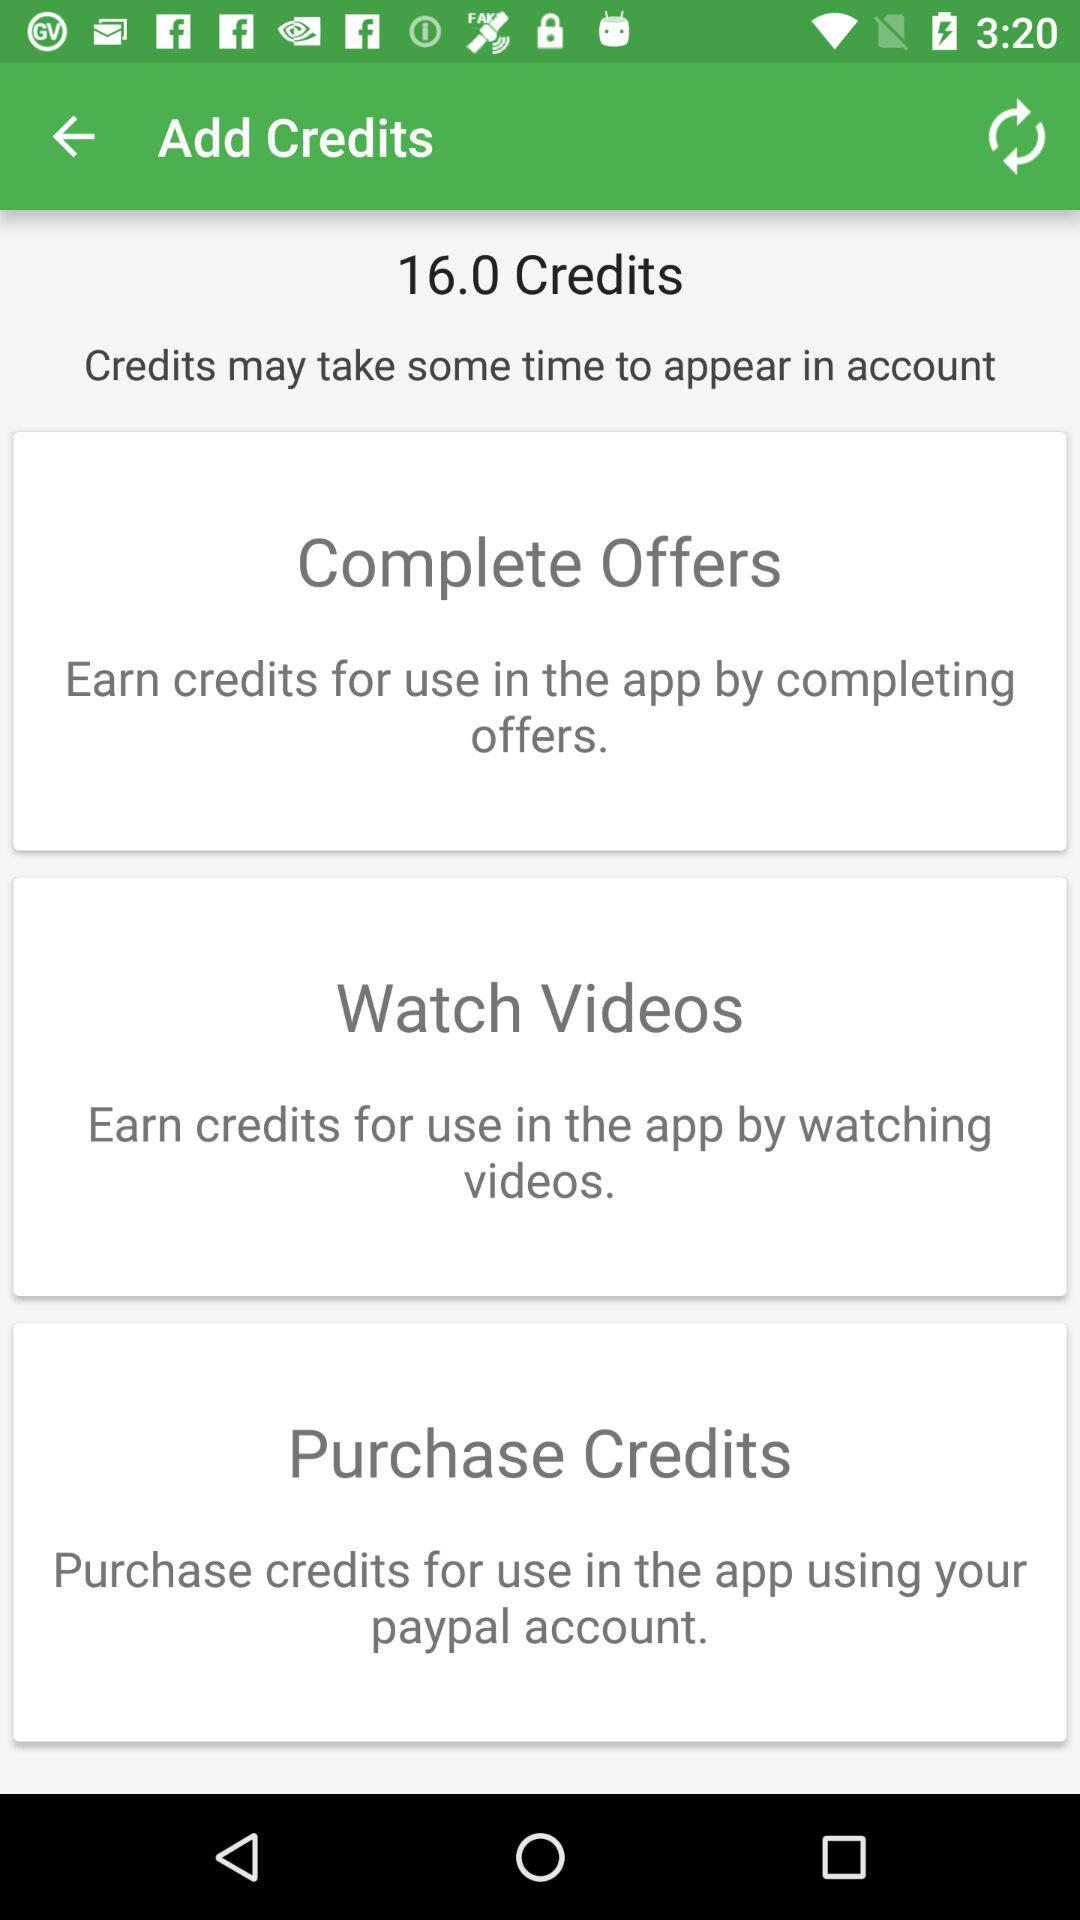How many credit points does the user have? The user has 16.0 credit points. 